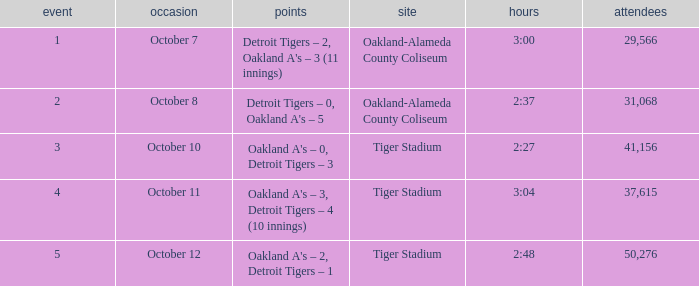What is the number of people in attendance when the time is 3:00? 29566.0. 